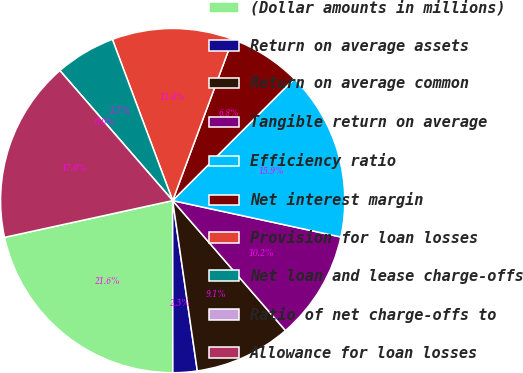<chart> <loc_0><loc_0><loc_500><loc_500><pie_chart><fcel>(Dollar amounts in millions)<fcel>Return on average assets<fcel>Return on average common<fcel>Tangible return on average<fcel>Efficiency ratio<fcel>Net interest margin<fcel>Provision for loan losses<fcel>Net loan and lease charge-offs<fcel>Ratio of net charge-offs to<fcel>Allowance for loan losses<nl><fcel>21.59%<fcel>2.27%<fcel>9.09%<fcel>10.23%<fcel>15.91%<fcel>6.82%<fcel>11.36%<fcel>5.68%<fcel>0.0%<fcel>17.05%<nl></chart> 